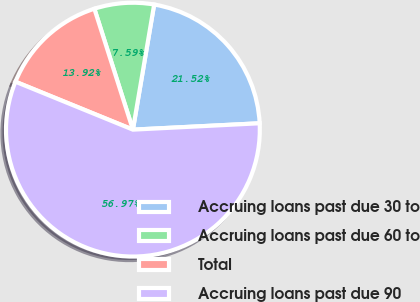<chart> <loc_0><loc_0><loc_500><loc_500><pie_chart><fcel>Accruing loans past due 30 to<fcel>Accruing loans past due 60 to<fcel>Total<fcel>Accruing loans past due 90<nl><fcel>21.52%<fcel>7.59%<fcel>13.92%<fcel>56.96%<nl></chart> 